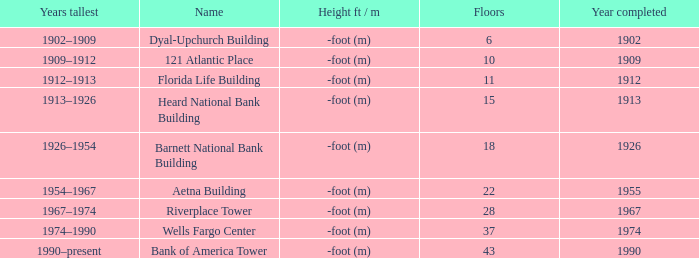What year did the completion of the 10-level building occur? 1909.0. 